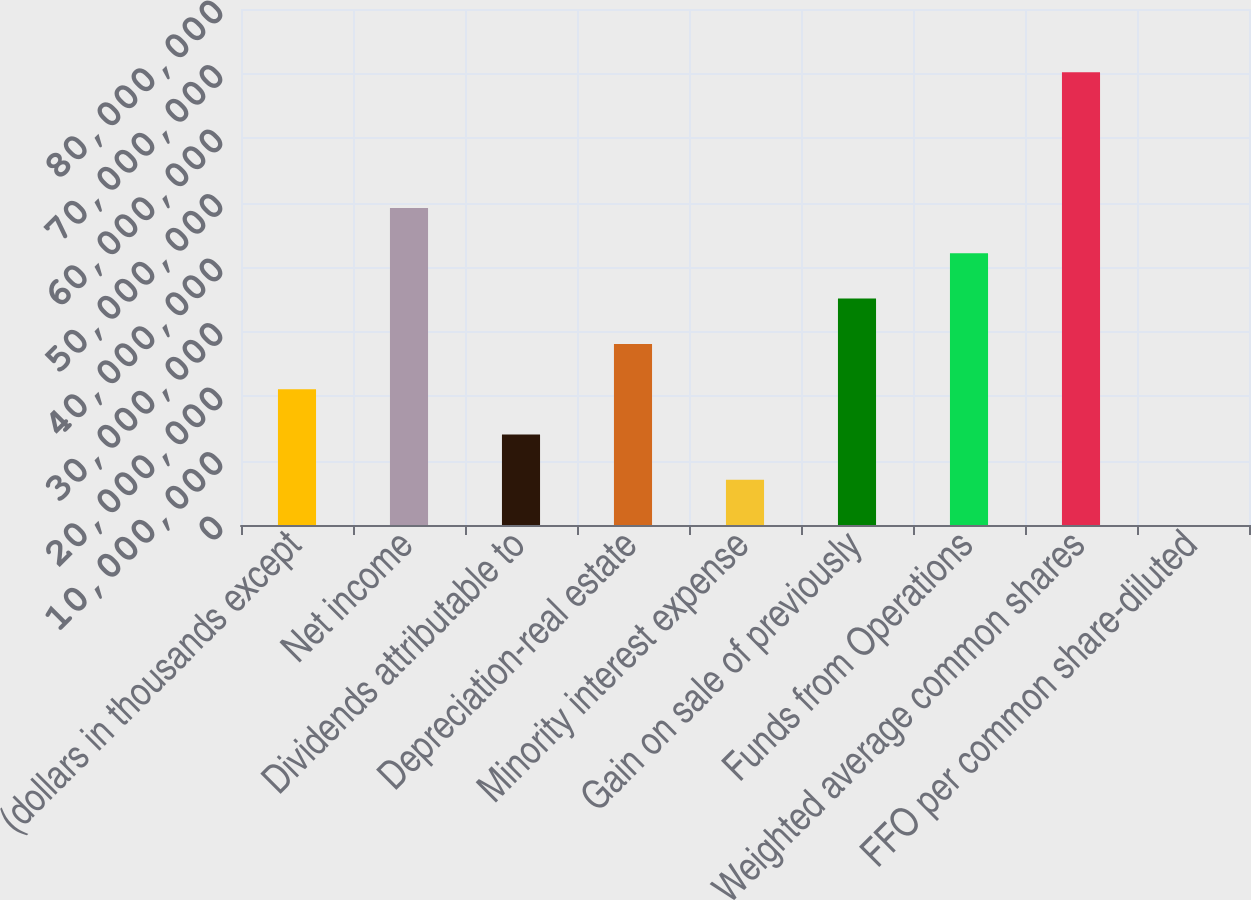<chart> <loc_0><loc_0><loc_500><loc_500><bar_chart><fcel>(dollars in thousands except<fcel>Net income<fcel>Dividends attributable to<fcel>Depreciation-real estate<fcel>Minority interest expense<fcel>Gain on sale of previously<fcel>Funds from Operations<fcel>Weighted average common shares<fcel>FFO per common share-diluted<nl><fcel>2.1061e+07<fcel>4.91424e+07<fcel>1.40407e+07<fcel>2.80814e+07<fcel>7.02035e+06<fcel>3.51017e+07<fcel>4.21221e+07<fcel>7.02035e+07<fcel>3.28<nl></chart> 